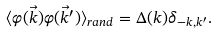Convert formula to latex. <formula><loc_0><loc_0><loc_500><loc_500>\langle \varphi ( \vec { k } ) \varphi ( \vec { k } ^ { \prime } ) \rangle _ { r a n d } = \Delta ( k ) \delta _ { - k , k ^ { \prime } } .</formula> 